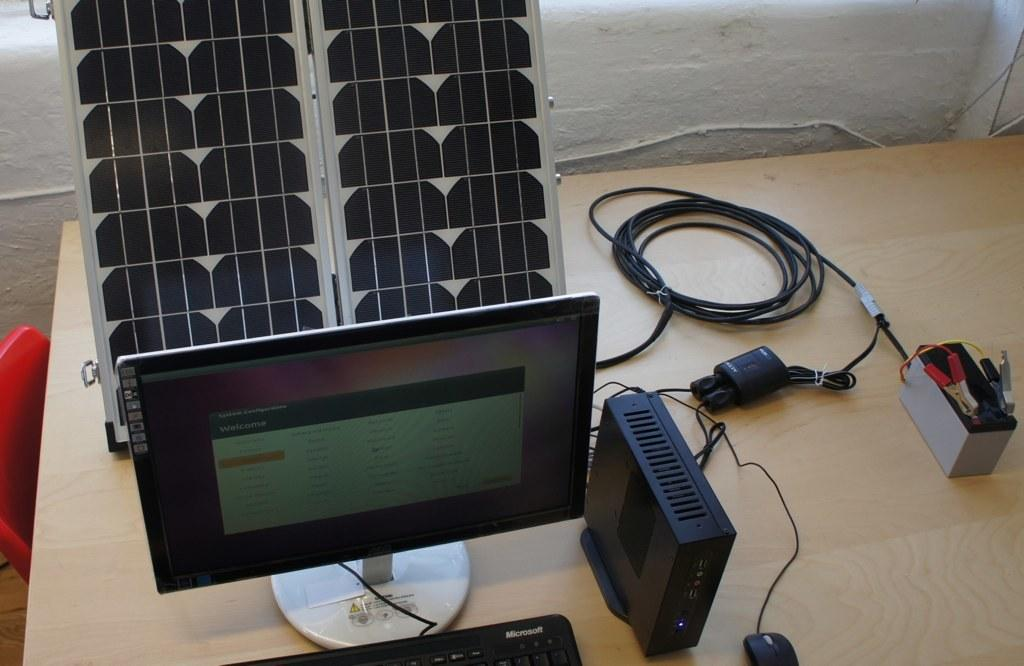What type of system is visible in the image? There is a system in the image, but the specific type is not mentioned. What is the energy source for the system? The solar board in the image suggests that it is powered by solar energy. How are the components of the system connected? The wires in the image indicate that the components are connected electrically. What type of storage units are present in the image? There are boxes in the image, which might be used for storing components or tools. Where are these items placed? These items are placed on a table, which provides a stable surface for the system. What color is the chair in the image? There is a red color chair in the image. What type of acoustics can be heard from the system in the image? There is no information about the system's acoustics in the image, so it cannot be determined. Is there a calculator visible on the table in the image? There is no mention of a calculator in the image, so it cannot be confirmed. What type of cabbage is being used as a component in the system? There is no cabbage present in the image, so it cannot be used as a component. 